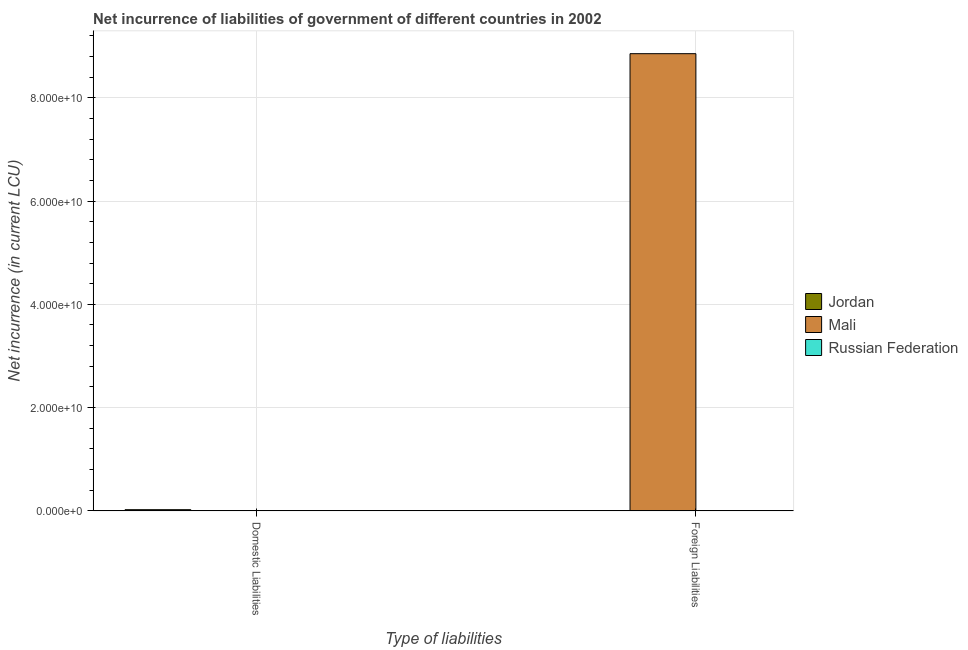How many different coloured bars are there?
Make the answer very short. 2. Are the number of bars per tick equal to the number of legend labels?
Offer a terse response. No. How many bars are there on the 2nd tick from the left?
Provide a short and direct response. 1. How many bars are there on the 2nd tick from the right?
Make the answer very short. 1. What is the label of the 1st group of bars from the left?
Give a very brief answer. Domestic Liabilities. What is the net incurrence of domestic liabilities in Jordan?
Give a very brief answer. 2.31e+08. Across all countries, what is the maximum net incurrence of domestic liabilities?
Provide a short and direct response. 2.31e+08. In which country was the net incurrence of foreign liabilities maximum?
Your answer should be compact. Mali. What is the total net incurrence of domestic liabilities in the graph?
Your answer should be compact. 2.31e+08. What is the difference between the net incurrence of domestic liabilities in Jordan and the net incurrence of foreign liabilities in Russian Federation?
Give a very brief answer. 2.31e+08. What is the average net incurrence of domestic liabilities per country?
Your response must be concise. 7.70e+07. In how many countries, is the net incurrence of foreign liabilities greater than 16000000000 LCU?
Offer a very short reply. 1. Are the values on the major ticks of Y-axis written in scientific E-notation?
Give a very brief answer. Yes. Does the graph contain any zero values?
Your answer should be very brief. Yes. Where does the legend appear in the graph?
Provide a short and direct response. Center right. How many legend labels are there?
Your answer should be compact. 3. What is the title of the graph?
Make the answer very short. Net incurrence of liabilities of government of different countries in 2002. What is the label or title of the X-axis?
Ensure brevity in your answer.  Type of liabilities. What is the label or title of the Y-axis?
Keep it short and to the point. Net incurrence (in current LCU). What is the Net incurrence (in current LCU) of Jordan in Domestic Liabilities?
Ensure brevity in your answer.  2.31e+08. What is the Net incurrence (in current LCU) of Mali in Domestic Liabilities?
Provide a succinct answer. 0. What is the Net incurrence (in current LCU) of Russian Federation in Domestic Liabilities?
Offer a very short reply. 0. What is the Net incurrence (in current LCU) in Jordan in Foreign Liabilities?
Ensure brevity in your answer.  0. What is the Net incurrence (in current LCU) of Mali in Foreign Liabilities?
Your answer should be compact. 8.85e+1. What is the Net incurrence (in current LCU) of Russian Federation in Foreign Liabilities?
Make the answer very short. 0. Across all Type of liabilities, what is the maximum Net incurrence (in current LCU) in Jordan?
Make the answer very short. 2.31e+08. Across all Type of liabilities, what is the maximum Net incurrence (in current LCU) of Mali?
Give a very brief answer. 8.85e+1. Across all Type of liabilities, what is the minimum Net incurrence (in current LCU) of Mali?
Keep it short and to the point. 0. What is the total Net incurrence (in current LCU) of Jordan in the graph?
Offer a terse response. 2.31e+08. What is the total Net incurrence (in current LCU) of Mali in the graph?
Make the answer very short. 8.85e+1. What is the difference between the Net incurrence (in current LCU) in Jordan in Domestic Liabilities and the Net incurrence (in current LCU) in Mali in Foreign Liabilities?
Your answer should be compact. -8.83e+1. What is the average Net incurrence (in current LCU) in Jordan per Type of liabilities?
Provide a short and direct response. 1.16e+08. What is the average Net incurrence (in current LCU) of Mali per Type of liabilities?
Ensure brevity in your answer.  4.43e+1. What is the difference between the highest and the lowest Net incurrence (in current LCU) of Jordan?
Offer a very short reply. 2.31e+08. What is the difference between the highest and the lowest Net incurrence (in current LCU) in Mali?
Your answer should be compact. 8.85e+1. 